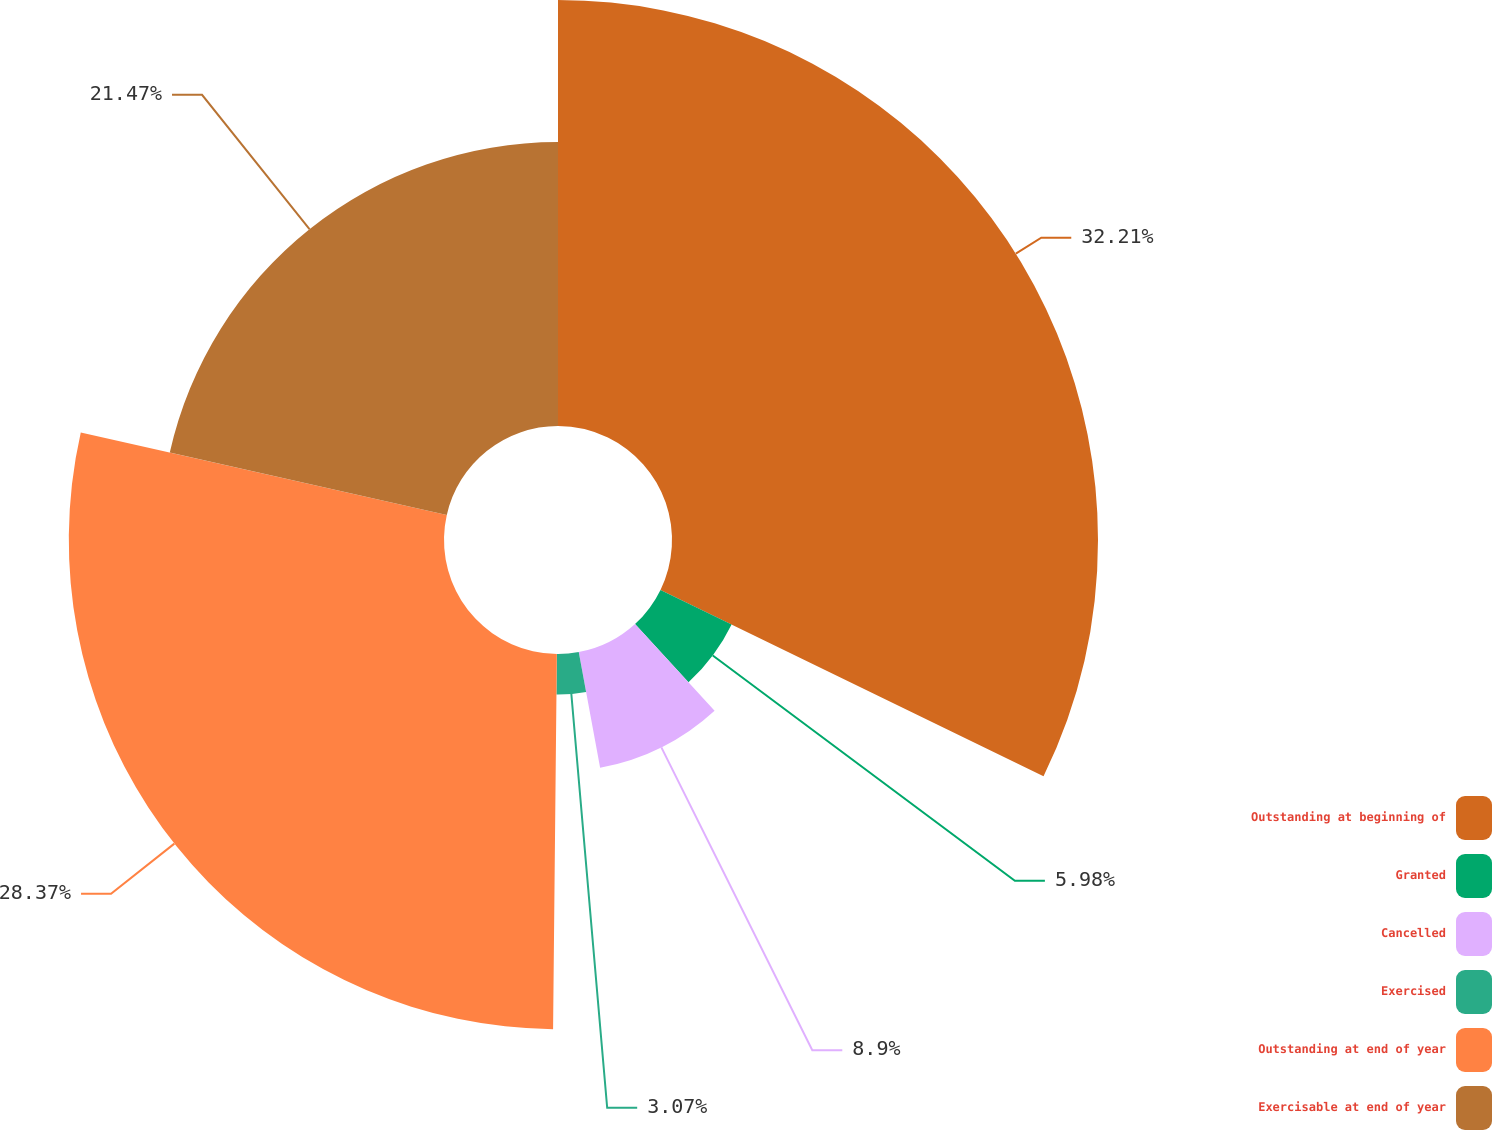<chart> <loc_0><loc_0><loc_500><loc_500><pie_chart><fcel>Outstanding at beginning of<fcel>Granted<fcel>Cancelled<fcel>Exercised<fcel>Outstanding at end of year<fcel>Exercisable at end of year<nl><fcel>32.21%<fcel>5.98%<fcel>8.9%<fcel>3.07%<fcel>28.37%<fcel>21.47%<nl></chart> 